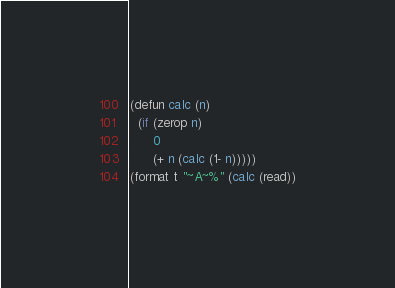<code> <loc_0><loc_0><loc_500><loc_500><_Lisp_>(defun calc (n)
  (if (zerop n)
      0
      (+ n (calc (1- n)))))
(format t "~A~%" (calc (read))
</code> 